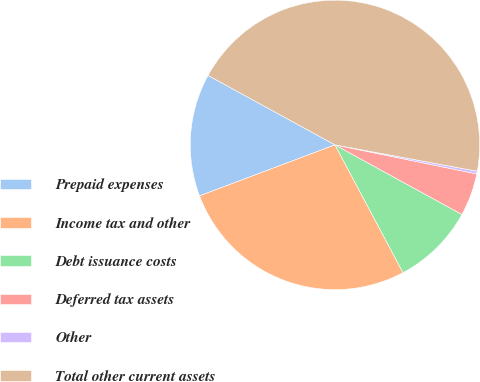<chart> <loc_0><loc_0><loc_500><loc_500><pie_chart><fcel>Prepaid expenses<fcel>Income tax and other<fcel>Debt issuance costs<fcel>Deferred tax assets<fcel>Other<fcel>Total other current assets<nl><fcel>13.7%<fcel>27.05%<fcel>9.23%<fcel>4.77%<fcel>0.3%<fcel>44.95%<nl></chart> 